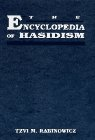What key topics does this encyclopedia cover? This encyclopedia covers a wide range of topics concerning Hasidic Judaism, including its origins, influential leaders, cultural practices, philosophical doctrines, and community life. It provides a detailed look at the sect's development over time and its current practices. Could you mention some specific entries or sections in the book? Certainly, some notable entries include the biographies of foundational figures like the Baal Shem Tov, descriptions of key rituals such as Tish and Farbrengen, and explanations of important concepts like Devekut and Tzimtzum. 